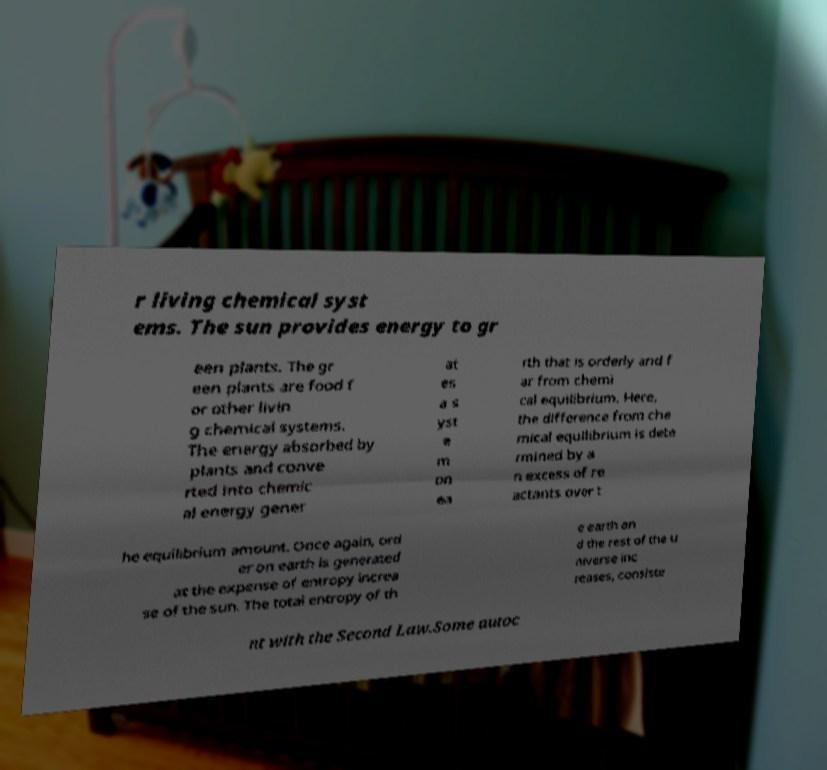For documentation purposes, I need the text within this image transcribed. Could you provide that? r living chemical syst ems. The sun provides energy to gr een plants. The gr een plants are food f or other livin g chemical systems. The energy absorbed by plants and conve rted into chemic al energy gener at es a s yst e m on ea rth that is orderly and f ar from chemi cal equilibrium. Here, the difference from che mical equilibrium is dete rmined by a n excess of re actants over t he equilibrium amount. Once again, ord er on earth is generated at the expense of entropy increa se of the sun. The total entropy of th e earth an d the rest of the u niverse inc reases, consiste nt with the Second Law.Some autoc 